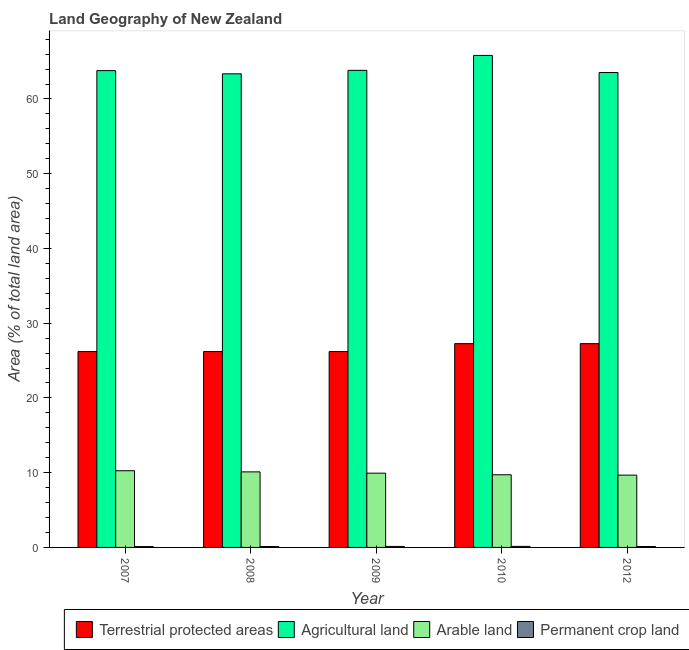How many different coloured bars are there?
Provide a succinct answer. 4. How many groups of bars are there?
Offer a terse response. 5. Are the number of bars on each tick of the X-axis equal?
Your answer should be very brief. Yes. What is the label of the 1st group of bars from the left?
Your answer should be compact. 2007. In how many cases, is the number of bars for a given year not equal to the number of legend labels?
Your answer should be very brief. 0. What is the percentage of area under permanent crop land in 2010?
Ensure brevity in your answer.  0.14. Across all years, what is the maximum percentage of area under arable land?
Keep it short and to the point. 10.26. Across all years, what is the minimum percentage of area under arable land?
Provide a succinct answer. 9.67. In which year was the percentage of area under permanent crop land maximum?
Provide a succinct answer. 2010. What is the total percentage of area under agricultural land in the graph?
Make the answer very short. 320.34. What is the difference between the percentage of area under permanent crop land in 2007 and that in 2010?
Your answer should be compact. -0.03. What is the difference between the percentage of area under permanent crop land in 2010 and the percentage of area under agricultural land in 2007?
Your answer should be very brief. 0.03. What is the average percentage of land under terrestrial protection per year?
Offer a terse response. 26.63. In how many years, is the percentage of area under agricultural land greater than 40 %?
Your answer should be compact. 5. What is the ratio of the percentage of area under arable land in 2008 to that in 2009?
Make the answer very short. 1.02. Is the difference between the percentage of area under arable land in 2009 and 2010 greater than the difference between the percentage of area under agricultural land in 2009 and 2010?
Offer a very short reply. No. What is the difference between the highest and the second highest percentage of area under agricultural land?
Ensure brevity in your answer.  1.99. What is the difference between the highest and the lowest percentage of area under permanent crop land?
Keep it short and to the point. 0.03. Is it the case that in every year, the sum of the percentage of area under permanent crop land and percentage of area under agricultural land is greater than the sum of percentage of land under terrestrial protection and percentage of area under arable land?
Make the answer very short. No. What does the 1st bar from the left in 2012 represents?
Make the answer very short. Terrestrial protected areas. What does the 1st bar from the right in 2012 represents?
Give a very brief answer. Permanent crop land. Are the values on the major ticks of Y-axis written in scientific E-notation?
Ensure brevity in your answer.  No. Does the graph contain any zero values?
Keep it short and to the point. No. Does the graph contain grids?
Give a very brief answer. No. Where does the legend appear in the graph?
Your response must be concise. Bottom right. What is the title of the graph?
Provide a succinct answer. Land Geography of New Zealand. What is the label or title of the X-axis?
Give a very brief answer. Year. What is the label or title of the Y-axis?
Ensure brevity in your answer.  Area (% of total land area). What is the Area (% of total land area) of Terrestrial protected areas in 2007?
Provide a short and direct response. 26.2. What is the Area (% of total land area) of Agricultural land in 2007?
Provide a short and direct response. 63.79. What is the Area (% of total land area) in Arable land in 2007?
Provide a succinct answer. 10.26. What is the Area (% of total land area) in Permanent crop land in 2007?
Make the answer very short. 0.11. What is the Area (% of total land area) in Terrestrial protected areas in 2008?
Your answer should be compact. 26.2. What is the Area (% of total land area) in Agricultural land in 2008?
Offer a terse response. 63.36. What is the Area (% of total land area) of Arable land in 2008?
Offer a very short reply. 10.11. What is the Area (% of total land area) in Permanent crop land in 2008?
Offer a terse response. 0.13. What is the Area (% of total land area) of Terrestrial protected areas in 2009?
Provide a succinct answer. 26.2. What is the Area (% of total land area) of Agricultural land in 2009?
Make the answer very short. 63.83. What is the Area (% of total land area) of Arable land in 2009?
Provide a short and direct response. 9.94. What is the Area (% of total land area) of Permanent crop land in 2009?
Ensure brevity in your answer.  0.13. What is the Area (% of total land area) of Terrestrial protected areas in 2010?
Give a very brief answer. 27.26. What is the Area (% of total land area) of Agricultural land in 2010?
Offer a terse response. 65.82. What is the Area (% of total land area) of Arable land in 2010?
Give a very brief answer. 9.72. What is the Area (% of total land area) in Permanent crop land in 2010?
Offer a very short reply. 0.14. What is the Area (% of total land area) in Terrestrial protected areas in 2012?
Your answer should be very brief. 27.26. What is the Area (% of total land area) of Agricultural land in 2012?
Offer a terse response. 63.53. What is the Area (% of total land area) in Arable land in 2012?
Ensure brevity in your answer.  9.67. What is the Area (% of total land area) in Permanent crop land in 2012?
Provide a succinct answer. 0.12. Across all years, what is the maximum Area (% of total land area) of Terrestrial protected areas?
Your response must be concise. 27.26. Across all years, what is the maximum Area (% of total land area) in Agricultural land?
Offer a terse response. 65.82. Across all years, what is the maximum Area (% of total land area) in Arable land?
Your answer should be compact. 10.26. Across all years, what is the maximum Area (% of total land area) of Permanent crop land?
Give a very brief answer. 0.14. Across all years, what is the minimum Area (% of total land area) of Terrestrial protected areas?
Provide a succinct answer. 26.2. Across all years, what is the minimum Area (% of total land area) of Agricultural land?
Give a very brief answer. 63.36. Across all years, what is the minimum Area (% of total land area) in Arable land?
Offer a terse response. 9.67. Across all years, what is the minimum Area (% of total land area) of Permanent crop land?
Give a very brief answer. 0.11. What is the total Area (% of total land area) of Terrestrial protected areas in the graph?
Make the answer very short. 133.14. What is the total Area (% of total land area) in Agricultural land in the graph?
Your answer should be very brief. 320.34. What is the total Area (% of total land area) of Arable land in the graph?
Offer a terse response. 49.7. What is the total Area (% of total land area) of Permanent crop land in the graph?
Provide a short and direct response. 0.63. What is the difference between the Area (% of total land area) of Terrestrial protected areas in 2007 and that in 2008?
Provide a short and direct response. 0. What is the difference between the Area (% of total land area) of Agricultural land in 2007 and that in 2008?
Your answer should be compact. 0.43. What is the difference between the Area (% of total land area) in Arable land in 2007 and that in 2008?
Your answer should be very brief. 0.16. What is the difference between the Area (% of total land area) of Permanent crop land in 2007 and that in 2008?
Your response must be concise. -0.01. What is the difference between the Area (% of total land area) of Agricultural land in 2007 and that in 2009?
Make the answer very short. -0.04. What is the difference between the Area (% of total land area) of Arable land in 2007 and that in 2009?
Provide a short and direct response. 0.33. What is the difference between the Area (% of total land area) of Permanent crop land in 2007 and that in 2009?
Offer a very short reply. -0.02. What is the difference between the Area (% of total land area) in Terrestrial protected areas in 2007 and that in 2010?
Your response must be concise. -1.06. What is the difference between the Area (% of total land area) in Agricultural land in 2007 and that in 2010?
Offer a very short reply. -2.03. What is the difference between the Area (% of total land area) in Arable land in 2007 and that in 2010?
Ensure brevity in your answer.  0.54. What is the difference between the Area (% of total land area) of Permanent crop land in 2007 and that in 2010?
Offer a terse response. -0.03. What is the difference between the Area (% of total land area) in Terrestrial protected areas in 2007 and that in 2012?
Ensure brevity in your answer.  -1.06. What is the difference between the Area (% of total land area) of Agricultural land in 2007 and that in 2012?
Make the answer very short. 0.26. What is the difference between the Area (% of total land area) of Arable land in 2007 and that in 2012?
Ensure brevity in your answer.  0.59. What is the difference between the Area (% of total land area) in Permanent crop land in 2007 and that in 2012?
Provide a succinct answer. -0.01. What is the difference between the Area (% of total land area) of Terrestrial protected areas in 2008 and that in 2009?
Your answer should be very brief. 0. What is the difference between the Area (% of total land area) in Agricultural land in 2008 and that in 2009?
Provide a succinct answer. -0.47. What is the difference between the Area (% of total land area) in Arable land in 2008 and that in 2009?
Give a very brief answer. 0.17. What is the difference between the Area (% of total land area) of Permanent crop land in 2008 and that in 2009?
Give a very brief answer. -0.01. What is the difference between the Area (% of total land area) of Terrestrial protected areas in 2008 and that in 2010?
Keep it short and to the point. -1.06. What is the difference between the Area (% of total land area) in Agricultural land in 2008 and that in 2010?
Your answer should be very brief. -2.46. What is the difference between the Area (% of total land area) of Arable land in 2008 and that in 2010?
Ensure brevity in your answer.  0.38. What is the difference between the Area (% of total land area) of Permanent crop land in 2008 and that in 2010?
Your answer should be compact. -0.02. What is the difference between the Area (% of total land area) of Terrestrial protected areas in 2008 and that in 2012?
Make the answer very short. -1.06. What is the difference between the Area (% of total land area) in Agricultural land in 2008 and that in 2012?
Keep it short and to the point. -0.17. What is the difference between the Area (% of total land area) of Arable land in 2008 and that in 2012?
Your response must be concise. 0.43. What is the difference between the Area (% of total land area) in Permanent crop land in 2008 and that in 2012?
Your answer should be compact. 0. What is the difference between the Area (% of total land area) in Terrestrial protected areas in 2009 and that in 2010?
Give a very brief answer. -1.06. What is the difference between the Area (% of total land area) in Agricultural land in 2009 and that in 2010?
Your answer should be compact. -1.99. What is the difference between the Area (% of total land area) in Arable land in 2009 and that in 2010?
Offer a terse response. 0.21. What is the difference between the Area (% of total land area) in Permanent crop land in 2009 and that in 2010?
Provide a short and direct response. -0.01. What is the difference between the Area (% of total land area) of Terrestrial protected areas in 2009 and that in 2012?
Your answer should be very brief. -1.06. What is the difference between the Area (% of total land area) in Agricultural land in 2009 and that in 2012?
Your answer should be compact. 0.3. What is the difference between the Area (% of total land area) of Arable land in 2009 and that in 2012?
Provide a short and direct response. 0.26. What is the difference between the Area (% of total land area) in Permanent crop land in 2009 and that in 2012?
Offer a very short reply. 0.01. What is the difference between the Area (% of total land area) of Agricultural land in 2010 and that in 2012?
Your response must be concise. 2.29. What is the difference between the Area (% of total land area) in Arable land in 2010 and that in 2012?
Provide a succinct answer. 0.05. What is the difference between the Area (% of total land area) in Permanent crop land in 2010 and that in 2012?
Ensure brevity in your answer.  0.02. What is the difference between the Area (% of total land area) in Terrestrial protected areas in 2007 and the Area (% of total land area) in Agricultural land in 2008?
Offer a very short reply. -37.16. What is the difference between the Area (% of total land area) of Terrestrial protected areas in 2007 and the Area (% of total land area) of Arable land in 2008?
Provide a short and direct response. 16.1. What is the difference between the Area (% of total land area) of Terrestrial protected areas in 2007 and the Area (% of total land area) of Permanent crop land in 2008?
Keep it short and to the point. 26.08. What is the difference between the Area (% of total land area) of Agricultural land in 2007 and the Area (% of total land area) of Arable land in 2008?
Offer a very short reply. 53.69. What is the difference between the Area (% of total land area) of Agricultural land in 2007 and the Area (% of total land area) of Permanent crop land in 2008?
Your response must be concise. 63.67. What is the difference between the Area (% of total land area) in Arable land in 2007 and the Area (% of total land area) in Permanent crop land in 2008?
Your answer should be compact. 10.14. What is the difference between the Area (% of total land area) of Terrestrial protected areas in 2007 and the Area (% of total land area) of Agricultural land in 2009?
Keep it short and to the point. -37.63. What is the difference between the Area (% of total land area) in Terrestrial protected areas in 2007 and the Area (% of total land area) in Arable land in 2009?
Offer a terse response. 16.27. What is the difference between the Area (% of total land area) in Terrestrial protected areas in 2007 and the Area (% of total land area) in Permanent crop land in 2009?
Keep it short and to the point. 26.07. What is the difference between the Area (% of total land area) of Agricultural land in 2007 and the Area (% of total land area) of Arable land in 2009?
Provide a short and direct response. 53.86. What is the difference between the Area (% of total land area) in Agricultural land in 2007 and the Area (% of total land area) in Permanent crop land in 2009?
Offer a very short reply. 63.66. What is the difference between the Area (% of total land area) in Arable land in 2007 and the Area (% of total land area) in Permanent crop land in 2009?
Your answer should be compact. 10.13. What is the difference between the Area (% of total land area) of Terrestrial protected areas in 2007 and the Area (% of total land area) of Agricultural land in 2010?
Provide a succinct answer. -39.62. What is the difference between the Area (% of total land area) of Terrestrial protected areas in 2007 and the Area (% of total land area) of Arable land in 2010?
Provide a short and direct response. 16.48. What is the difference between the Area (% of total land area) of Terrestrial protected areas in 2007 and the Area (% of total land area) of Permanent crop land in 2010?
Offer a terse response. 26.06. What is the difference between the Area (% of total land area) of Agricultural land in 2007 and the Area (% of total land area) of Arable land in 2010?
Offer a terse response. 54.07. What is the difference between the Area (% of total land area) of Agricultural land in 2007 and the Area (% of total land area) of Permanent crop land in 2010?
Keep it short and to the point. 63.65. What is the difference between the Area (% of total land area) in Arable land in 2007 and the Area (% of total land area) in Permanent crop land in 2010?
Your response must be concise. 10.12. What is the difference between the Area (% of total land area) of Terrestrial protected areas in 2007 and the Area (% of total land area) of Agricultural land in 2012?
Provide a short and direct response. -37.33. What is the difference between the Area (% of total land area) in Terrestrial protected areas in 2007 and the Area (% of total land area) in Arable land in 2012?
Keep it short and to the point. 16.53. What is the difference between the Area (% of total land area) of Terrestrial protected areas in 2007 and the Area (% of total land area) of Permanent crop land in 2012?
Your answer should be compact. 26.08. What is the difference between the Area (% of total land area) in Agricultural land in 2007 and the Area (% of total land area) in Arable land in 2012?
Provide a succinct answer. 54.12. What is the difference between the Area (% of total land area) in Agricultural land in 2007 and the Area (% of total land area) in Permanent crop land in 2012?
Your answer should be compact. 63.67. What is the difference between the Area (% of total land area) in Arable land in 2007 and the Area (% of total land area) in Permanent crop land in 2012?
Give a very brief answer. 10.14. What is the difference between the Area (% of total land area) of Terrestrial protected areas in 2008 and the Area (% of total land area) of Agricultural land in 2009?
Offer a very short reply. -37.63. What is the difference between the Area (% of total land area) of Terrestrial protected areas in 2008 and the Area (% of total land area) of Arable land in 2009?
Give a very brief answer. 16.27. What is the difference between the Area (% of total land area) of Terrestrial protected areas in 2008 and the Area (% of total land area) of Permanent crop land in 2009?
Make the answer very short. 26.07. What is the difference between the Area (% of total land area) in Agricultural land in 2008 and the Area (% of total land area) in Arable land in 2009?
Make the answer very short. 53.43. What is the difference between the Area (% of total land area) in Agricultural land in 2008 and the Area (% of total land area) in Permanent crop land in 2009?
Give a very brief answer. 63.23. What is the difference between the Area (% of total land area) in Arable land in 2008 and the Area (% of total land area) in Permanent crop land in 2009?
Provide a short and direct response. 9.97. What is the difference between the Area (% of total land area) in Terrestrial protected areas in 2008 and the Area (% of total land area) in Agricultural land in 2010?
Provide a short and direct response. -39.62. What is the difference between the Area (% of total land area) in Terrestrial protected areas in 2008 and the Area (% of total land area) in Arable land in 2010?
Your response must be concise. 16.48. What is the difference between the Area (% of total land area) in Terrestrial protected areas in 2008 and the Area (% of total land area) in Permanent crop land in 2010?
Give a very brief answer. 26.06. What is the difference between the Area (% of total land area) of Agricultural land in 2008 and the Area (% of total land area) of Arable land in 2010?
Provide a short and direct response. 53.64. What is the difference between the Area (% of total land area) of Agricultural land in 2008 and the Area (% of total land area) of Permanent crop land in 2010?
Give a very brief answer. 63.22. What is the difference between the Area (% of total land area) of Arable land in 2008 and the Area (% of total land area) of Permanent crop land in 2010?
Offer a very short reply. 9.97. What is the difference between the Area (% of total land area) of Terrestrial protected areas in 2008 and the Area (% of total land area) of Agricultural land in 2012?
Keep it short and to the point. -37.33. What is the difference between the Area (% of total land area) of Terrestrial protected areas in 2008 and the Area (% of total land area) of Arable land in 2012?
Provide a short and direct response. 16.53. What is the difference between the Area (% of total land area) of Terrestrial protected areas in 2008 and the Area (% of total land area) of Permanent crop land in 2012?
Make the answer very short. 26.08. What is the difference between the Area (% of total land area) of Agricultural land in 2008 and the Area (% of total land area) of Arable land in 2012?
Give a very brief answer. 53.69. What is the difference between the Area (% of total land area) of Agricultural land in 2008 and the Area (% of total land area) of Permanent crop land in 2012?
Your answer should be very brief. 63.24. What is the difference between the Area (% of total land area) in Arable land in 2008 and the Area (% of total land area) in Permanent crop land in 2012?
Provide a succinct answer. 9.98. What is the difference between the Area (% of total land area) of Terrestrial protected areas in 2009 and the Area (% of total land area) of Agricultural land in 2010?
Keep it short and to the point. -39.62. What is the difference between the Area (% of total land area) in Terrestrial protected areas in 2009 and the Area (% of total land area) in Arable land in 2010?
Offer a terse response. 16.48. What is the difference between the Area (% of total land area) of Terrestrial protected areas in 2009 and the Area (% of total land area) of Permanent crop land in 2010?
Give a very brief answer. 26.06. What is the difference between the Area (% of total land area) in Agricultural land in 2009 and the Area (% of total land area) in Arable land in 2010?
Your answer should be compact. 54.11. What is the difference between the Area (% of total land area) in Agricultural land in 2009 and the Area (% of total land area) in Permanent crop land in 2010?
Ensure brevity in your answer.  63.69. What is the difference between the Area (% of total land area) in Arable land in 2009 and the Area (% of total land area) in Permanent crop land in 2010?
Your response must be concise. 9.79. What is the difference between the Area (% of total land area) in Terrestrial protected areas in 2009 and the Area (% of total land area) in Agricultural land in 2012?
Your answer should be very brief. -37.33. What is the difference between the Area (% of total land area) of Terrestrial protected areas in 2009 and the Area (% of total land area) of Arable land in 2012?
Provide a succinct answer. 16.53. What is the difference between the Area (% of total land area) of Terrestrial protected areas in 2009 and the Area (% of total land area) of Permanent crop land in 2012?
Your answer should be compact. 26.08. What is the difference between the Area (% of total land area) in Agricultural land in 2009 and the Area (% of total land area) in Arable land in 2012?
Provide a short and direct response. 54.16. What is the difference between the Area (% of total land area) in Agricultural land in 2009 and the Area (% of total land area) in Permanent crop land in 2012?
Provide a succinct answer. 63.71. What is the difference between the Area (% of total land area) in Arable land in 2009 and the Area (% of total land area) in Permanent crop land in 2012?
Offer a terse response. 9.81. What is the difference between the Area (% of total land area) of Terrestrial protected areas in 2010 and the Area (% of total land area) of Agricultural land in 2012?
Keep it short and to the point. -36.27. What is the difference between the Area (% of total land area) of Terrestrial protected areas in 2010 and the Area (% of total land area) of Arable land in 2012?
Ensure brevity in your answer.  17.59. What is the difference between the Area (% of total land area) in Terrestrial protected areas in 2010 and the Area (% of total land area) in Permanent crop land in 2012?
Provide a succinct answer. 27.14. What is the difference between the Area (% of total land area) in Agricultural land in 2010 and the Area (% of total land area) in Arable land in 2012?
Offer a terse response. 56.15. What is the difference between the Area (% of total land area) of Agricultural land in 2010 and the Area (% of total land area) of Permanent crop land in 2012?
Make the answer very short. 65.7. What is the difference between the Area (% of total land area) in Arable land in 2010 and the Area (% of total land area) in Permanent crop land in 2012?
Your answer should be very brief. 9.6. What is the average Area (% of total land area) of Terrestrial protected areas per year?
Provide a succinct answer. 26.63. What is the average Area (% of total land area) in Agricultural land per year?
Offer a very short reply. 64.07. What is the average Area (% of total land area) in Arable land per year?
Provide a succinct answer. 9.94. What is the average Area (% of total land area) of Permanent crop land per year?
Offer a very short reply. 0.13. In the year 2007, what is the difference between the Area (% of total land area) of Terrestrial protected areas and Area (% of total land area) of Agricultural land?
Your answer should be very brief. -37.59. In the year 2007, what is the difference between the Area (% of total land area) in Terrestrial protected areas and Area (% of total land area) in Arable land?
Offer a very short reply. 15.94. In the year 2007, what is the difference between the Area (% of total land area) of Terrestrial protected areas and Area (% of total land area) of Permanent crop land?
Keep it short and to the point. 26.09. In the year 2007, what is the difference between the Area (% of total land area) in Agricultural land and Area (% of total land area) in Arable land?
Ensure brevity in your answer.  53.53. In the year 2007, what is the difference between the Area (% of total land area) in Agricultural land and Area (% of total land area) in Permanent crop land?
Your response must be concise. 63.68. In the year 2007, what is the difference between the Area (% of total land area) of Arable land and Area (% of total land area) of Permanent crop land?
Provide a short and direct response. 10.15. In the year 2008, what is the difference between the Area (% of total land area) in Terrestrial protected areas and Area (% of total land area) in Agricultural land?
Provide a succinct answer. -37.16. In the year 2008, what is the difference between the Area (% of total land area) of Terrestrial protected areas and Area (% of total land area) of Arable land?
Make the answer very short. 16.1. In the year 2008, what is the difference between the Area (% of total land area) of Terrestrial protected areas and Area (% of total land area) of Permanent crop land?
Your answer should be compact. 26.08. In the year 2008, what is the difference between the Area (% of total land area) of Agricultural land and Area (% of total land area) of Arable land?
Make the answer very short. 53.26. In the year 2008, what is the difference between the Area (% of total land area) of Agricultural land and Area (% of total land area) of Permanent crop land?
Your answer should be compact. 63.24. In the year 2008, what is the difference between the Area (% of total land area) in Arable land and Area (% of total land area) in Permanent crop land?
Keep it short and to the point. 9.98. In the year 2009, what is the difference between the Area (% of total land area) of Terrestrial protected areas and Area (% of total land area) of Agricultural land?
Offer a terse response. -37.63. In the year 2009, what is the difference between the Area (% of total land area) in Terrestrial protected areas and Area (% of total land area) in Arable land?
Your answer should be very brief. 16.27. In the year 2009, what is the difference between the Area (% of total land area) of Terrestrial protected areas and Area (% of total land area) of Permanent crop land?
Your answer should be compact. 26.07. In the year 2009, what is the difference between the Area (% of total land area) of Agricultural land and Area (% of total land area) of Arable land?
Your response must be concise. 53.89. In the year 2009, what is the difference between the Area (% of total land area) of Agricultural land and Area (% of total land area) of Permanent crop land?
Your response must be concise. 63.7. In the year 2009, what is the difference between the Area (% of total land area) of Arable land and Area (% of total land area) of Permanent crop land?
Your response must be concise. 9.8. In the year 2010, what is the difference between the Area (% of total land area) in Terrestrial protected areas and Area (% of total land area) in Agricultural land?
Provide a short and direct response. -38.56. In the year 2010, what is the difference between the Area (% of total land area) of Terrestrial protected areas and Area (% of total land area) of Arable land?
Ensure brevity in your answer.  17.54. In the year 2010, what is the difference between the Area (% of total land area) in Terrestrial protected areas and Area (% of total land area) in Permanent crop land?
Ensure brevity in your answer.  27.12. In the year 2010, what is the difference between the Area (% of total land area) of Agricultural land and Area (% of total land area) of Arable land?
Provide a succinct answer. 56.1. In the year 2010, what is the difference between the Area (% of total land area) of Agricultural land and Area (% of total land area) of Permanent crop land?
Offer a very short reply. 65.68. In the year 2010, what is the difference between the Area (% of total land area) of Arable land and Area (% of total land area) of Permanent crop land?
Your answer should be compact. 9.58. In the year 2012, what is the difference between the Area (% of total land area) of Terrestrial protected areas and Area (% of total land area) of Agricultural land?
Keep it short and to the point. -36.27. In the year 2012, what is the difference between the Area (% of total land area) in Terrestrial protected areas and Area (% of total land area) in Arable land?
Provide a short and direct response. 17.59. In the year 2012, what is the difference between the Area (% of total land area) of Terrestrial protected areas and Area (% of total land area) of Permanent crop land?
Your response must be concise. 27.14. In the year 2012, what is the difference between the Area (% of total land area) of Agricultural land and Area (% of total land area) of Arable land?
Make the answer very short. 53.86. In the year 2012, what is the difference between the Area (% of total land area) in Agricultural land and Area (% of total land area) in Permanent crop land?
Provide a succinct answer. 63.41. In the year 2012, what is the difference between the Area (% of total land area) in Arable land and Area (% of total land area) in Permanent crop land?
Your response must be concise. 9.55. What is the ratio of the Area (% of total land area) in Terrestrial protected areas in 2007 to that in 2008?
Offer a terse response. 1. What is the ratio of the Area (% of total land area) in Agricultural land in 2007 to that in 2008?
Make the answer very short. 1.01. What is the ratio of the Area (% of total land area) in Arable land in 2007 to that in 2008?
Offer a terse response. 1.02. What is the ratio of the Area (% of total land area) of Agricultural land in 2007 to that in 2009?
Provide a short and direct response. 1. What is the ratio of the Area (% of total land area) in Arable land in 2007 to that in 2009?
Offer a very short reply. 1.03. What is the ratio of the Area (% of total land area) in Terrestrial protected areas in 2007 to that in 2010?
Ensure brevity in your answer.  0.96. What is the ratio of the Area (% of total land area) in Agricultural land in 2007 to that in 2010?
Provide a short and direct response. 0.97. What is the ratio of the Area (% of total land area) in Arable land in 2007 to that in 2010?
Keep it short and to the point. 1.06. What is the ratio of the Area (% of total land area) of Permanent crop land in 2007 to that in 2010?
Give a very brief answer. 0.81. What is the ratio of the Area (% of total land area) in Terrestrial protected areas in 2007 to that in 2012?
Ensure brevity in your answer.  0.96. What is the ratio of the Area (% of total land area) of Arable land in 2007 to that in 2012?
Ensure brevity in your answer.  1.06. What is the ratio of the Area (% of total land area) of Arable land in 2008 to that in 2009?
Make the answer very short. 1.02. What is the ratio of the Area (% of total land area) of Permanent crop land in 2008 to that in 2009?
Your answer should be very brief. 0.94. What is the ratio of the Area (% of total land area) of Terrestrial protected areas in 2008 to that in 2010?
Provide a short and direct response. 0.96. What is the ratio of the Area (% of total land area) in Agricultural land in 2008 to that in 2010?
Offer a terse response. 0.96. What is the ratio of the Area (% of total land area) in Arable land in 2008 to that in 2010?
Give a very brief answer. 1.04. What is the ratio of the Area (% of total land area) in Permanent crop land in 2008 to that in 2010?
Ensure brevity in your answer.  0.89. What is the ratio of the Area (% of total land area) in Terrestrial protected areas in 2008 to that in 2012?
Provide a short and direct response. 0.96. What is the ratio of the Area (% of total land area) of Arable land in 2008 to that in 2012?
Give a very brief answer. 1.04. What is the ratio of the Area (% of total land area) in Permanent crop land in 2008 to that in 2012?
Provide a short and direct response. 1.03. What is the ratio of the Area (% of total land area) of Terrestrial protected areas in 2009 to that in 2010?
Provide a succinct answer. 0.96. What is the ratio of the Area (% of total land area) in Agricultural land in 2009 to that in 2010?
Keep it short and to the point. 0.97. What is the ratio of the Area (% of total land area) of Arable land in 2009 to that in 2010?
Offer a terse response. 1.02. What is the ratio of the Area (% of total land area) in Permanent crop land in 2009 to that in 2010?
Your answer should be compact. 0.95. What is the ratio of the Area (% of total land area) in Terrestrial protected areas in 2009 to that in 2012?
Your answer should be compact. 0.96. What is the ratio of the Area (% of total land area) in Agricultural land in 2009 to that in 2012?
Provide a short and direct response. 1. What is the ratio of the Area (% of total land area) in Arable land in 2009 to that in 2012?
Keep it short and to the point. 1.03. What is the ratio of the Area (% of total land area) in Permanent crop land in 2009 to that in 2012?
Your response must be concise. 1.09. What is the ratio of the Area (% of total land area) in Agricultural land in 2010 to that in 2012?
Offer a terse response. 1.04. What is the ratio of the Area (% of total land area) of Permanent crop land in 2010 to that in 2012?
Give a very brief answer. 1.16. What is the difference between the highest and the second highest Area (% of total land area) of Agricultural land?
Your response must be concise. 1.99. What is the difference between the highest and the second highest Area (% of total land area) of Arable land?
Your response must be concise. 0.16. What is the difference between the highest and the second highest Area (% of total land area) in Permanent crop land?
Offer a terse response. 0.01. What is the difference between the highest and the lowest Area (% of total land area) in Terrestrial protected areas?
Your answer should be very brief. 1.06. What is the difference between the highest and the lowest Area (% of total land area) of Agricultural land?
Ensure brevity in your answer.  2.46. What is the difference between the highest and the lowest Area (% of total land area) of Arable land?
Your answer should be very brief. 0.59. What is the difference between the highest and the lowest Area (% of total land area) in Permanent crop land?
Make the answer very short. 0.03. 